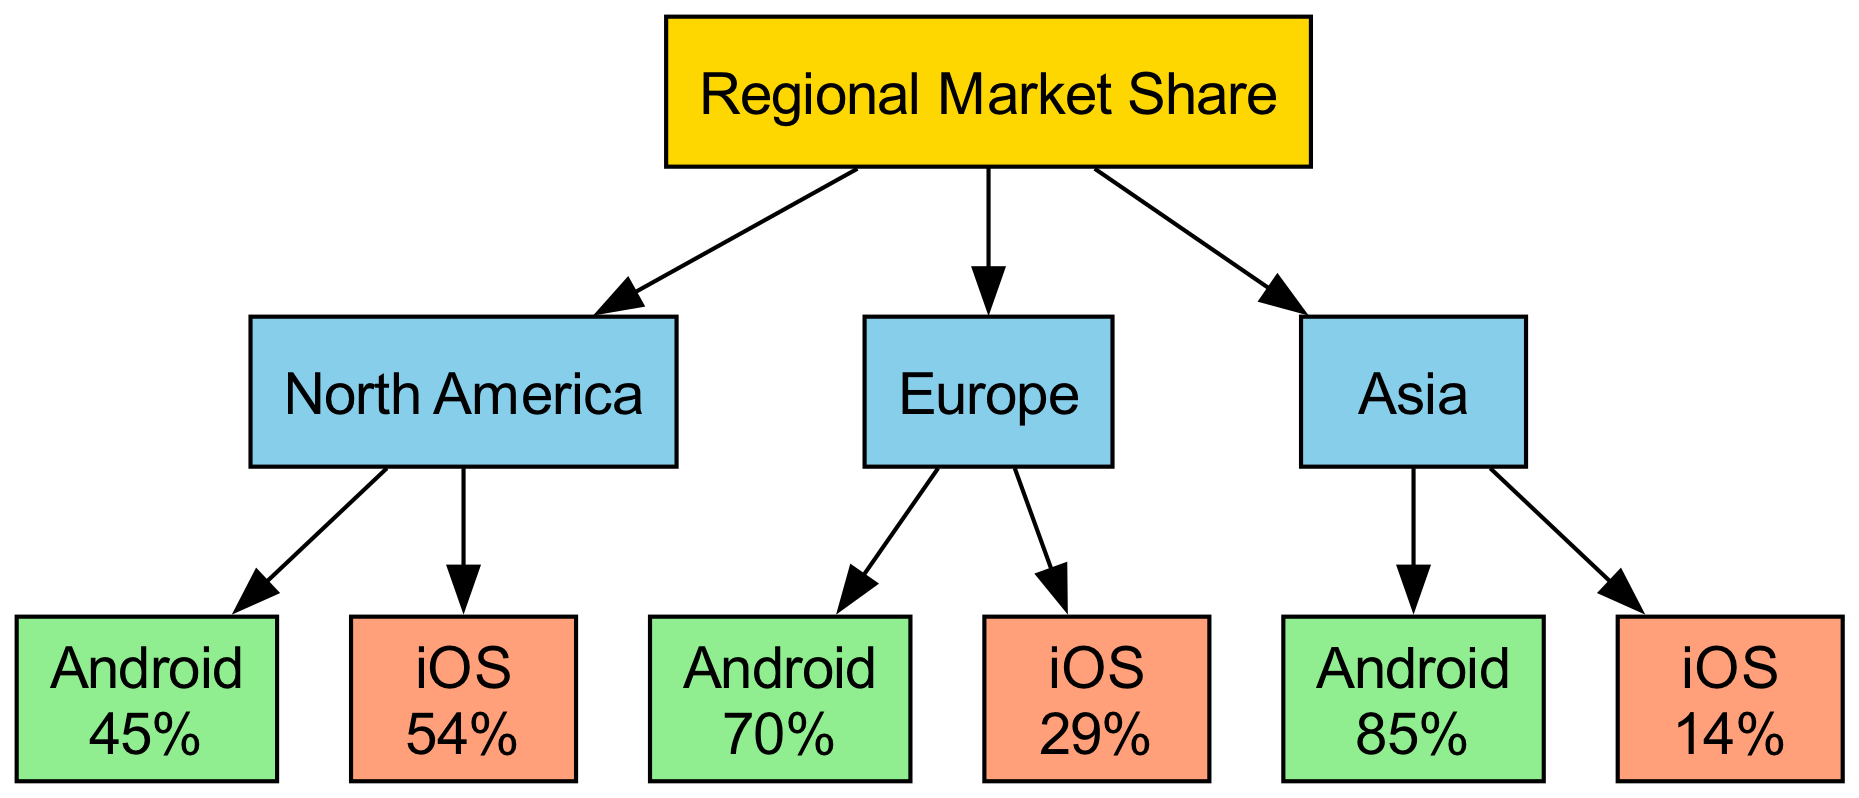What is the market share of Android in North America? Looking at the North America region in the diagram, the Android market share is clearly indicated as 45%.
Answer: 45% What is the market share of iOS in Europe? The Europe region shows that iOS has a market share of 29%, as labeled in that section of the diagram.
Answer: 29% Which region has the highest Android market share? By comparing the market shares, Asia has the highest Android market share at 85%, which is the largest value among all the regions listed.
Answer: 85% Which region has a higher market share for iOS, North America or Europe? In North America, iOS has a share of 54%, while in Europe, it has a share of 29%. Therefore, North America has a higher market share for iOS.
Answer: North America How many operating systems are compared in the diagram? The diagram compares two operating systems, Android and iOS, across three regions. Therefore, there are two operating systems shown.
Answer: 2 Is the market share of Android greater than iOS in all regions? By examining each region, Android has a greater market share than iOS in Europe (70% vs 29%) and Asia (85% vs 14%), but not in North America (45% vs 54%). Thus, the statement is false.
Answer: No Which operating system has a greater market share in Asia? The Asia region indicates that Android has a market share of 85% while iOS only has 14%. Thus, Android has the greater market share in Asia.
Answer: Android What can be inferred about the trend in Android and iOS market shares between the regions? Analyzing the data reveals that Android's market share significantly increases from North America to Asia, suggesting a trend where Android becomes more dominant in the Asian market, while iOS decreases as we move from North America to Asia.
Answer: Android becomes more dominant in Asia 